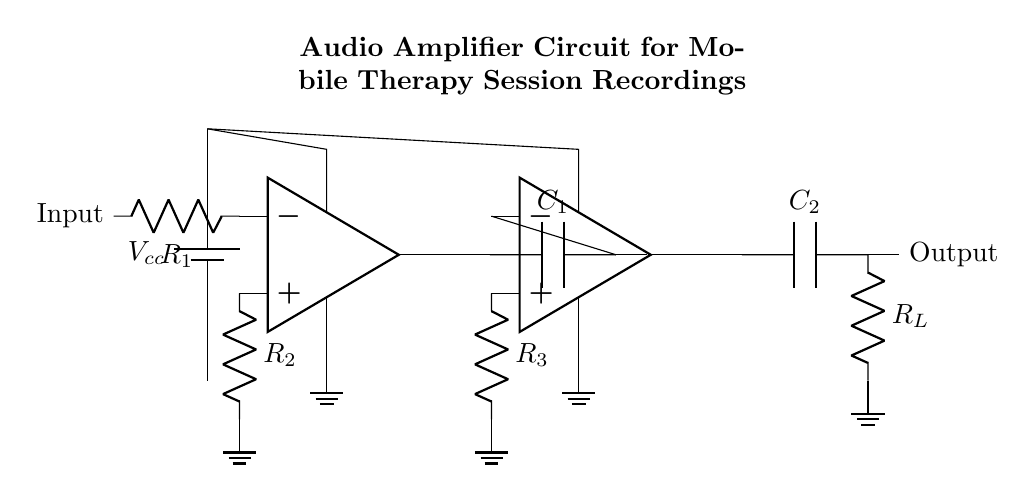What type of circuit is shown in the diagram? The circuit is an audio amplifier circuit, which is designed to increase the amplitude of audio signals. This can be inferred from the presence of operational amplifiers and passive components typically used in audio applications.
Answer: audio amplifier What are the names of the components used in the gain stage? The components in the gain stage include an operational amplifier and a capacitor. The operational amplifier is the main component responsible for amplifying the signal, while the capacitor is used for coupling or filtering within the circuit.
Answer: operational amplifier, capacitor How many resistors are present in the circuit? There are three resistors shown in the circuit. They are labeled as R1, R2, and R3, which are part of the input and gain stages of the amplifier.
Answer: three What is the function of capacitor C1 in the circuit? Capacitor C1 is used to couple the output of the first operational amplifier to the input of the second operational amplifier, allowing the audio signal to pass while blocking any DC component. This function helps to ensure that only the desired audio frequencies are amplified further.
Answer: coupling What are the connection points for power supply in the circuit? The power supply connection points are located at the top of both operational amplifiers, labeled as Vcc. These points indicate where the positive voltage is supplied to power the amplifiers, and both are grounded at the bottom.
Answer: Vcc at both op-amps What is the role of resistor R_L in this audio amplifier circuit? Resistor R_L functions as the load resistor in the output stage of the amplifier. It is crucial as it determines the output impedance of the circuit, affecting how the amplified signal interacts with any connected devices or speakers, thereby ensuring proper load operation.
Answer: load resistor What is the purpose of using two operational amplifiers in this circuit? The use of two operational amplifiers allows for higher overall gain and better control over the frequency response of the amplifier. The first op-amp primarily handles initial amplification, while the second can refine the signal further, improving sound quality in recordings.
Answer: higher gain, better frequency response 